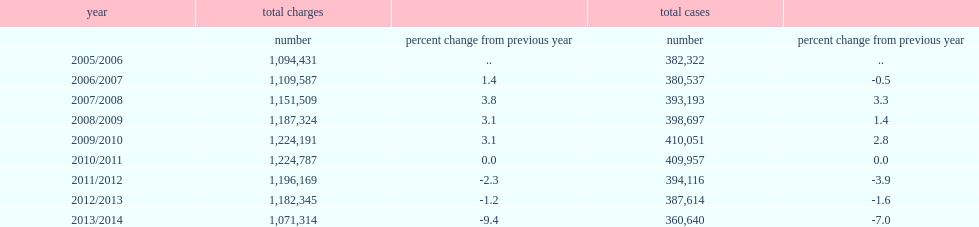In 2013/2014, how many cases completed in adult criminal court? 360640.0. In 2013/2014, what percentage of the completed cases has changed from the previous year? -7.0. 